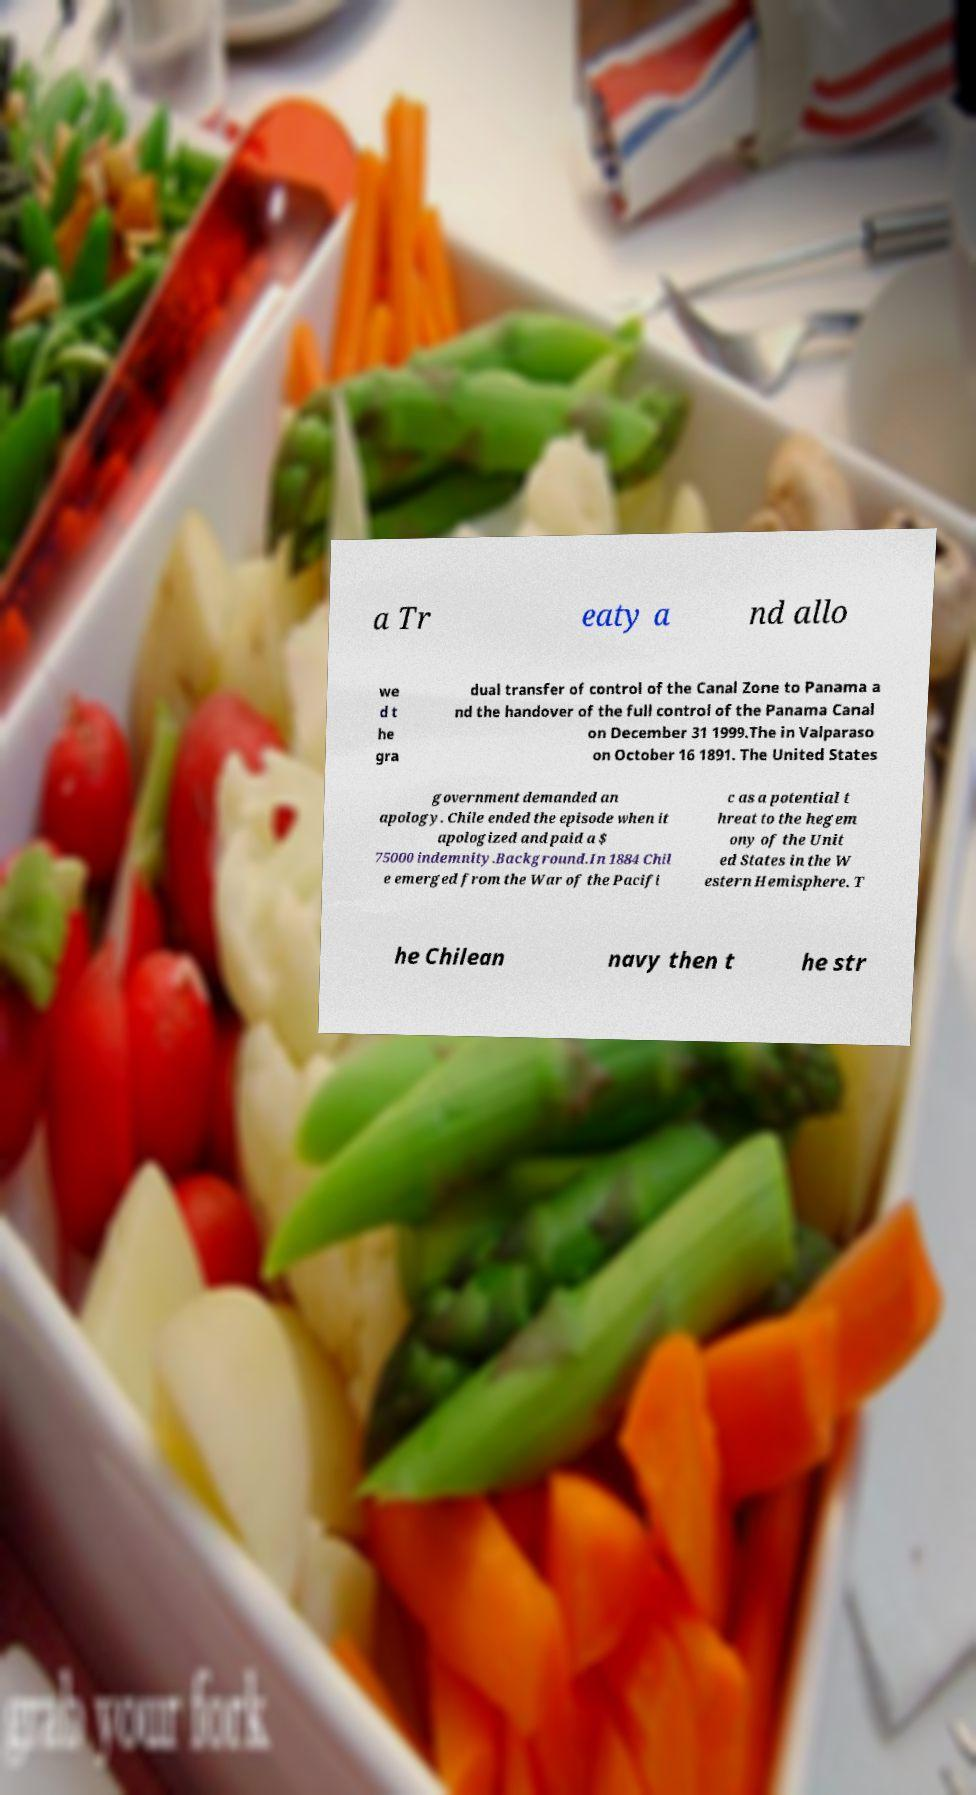What messages or text are displayed in this image? I need them in a readable, typed format. a Tr eaty a nd allo we d t he gra dual transfer of control of the Canal Zone to Panama a nd the handover of the full control of the Panama Canal on December 31 1999.The in Valparaso on October 16 1891. The United States government demanded an apology. Chile ended the episode when it apologized and paid a $ 75000 indemnity.Background.In 1884 Chil e emerged from the War of the Pacifi c as a potential t hreat to the hegem ony of the Unit ed States in the W estern Hemisphere. T he Chilean navy then t he str 